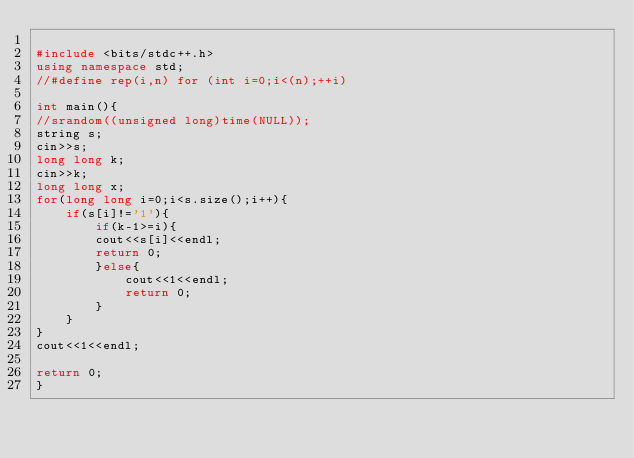Convert code to text. <code><loc_0><loc_0><loc_500><loc_500><_C++_>
#include <bits/stdc++.h>
using namespace std;
//#define rep(i,n) for (int i=0;i<(n);++i)

int main(){
//srandom((unsigned long)time(NULL));
string s;
cin>>s;
long long k;
cin>>k;
long long x;
for(long long i=0;i<s.size();i++){
    if(s[i]!='1'){
        if(k-1>=i){
        cout<<s[i]<<endl;
        return 0;
        }else{
            cout<<1<<endl;
            return 0;
        }
    }
}
cout<<1<<endl;

return 0;
}</code> 